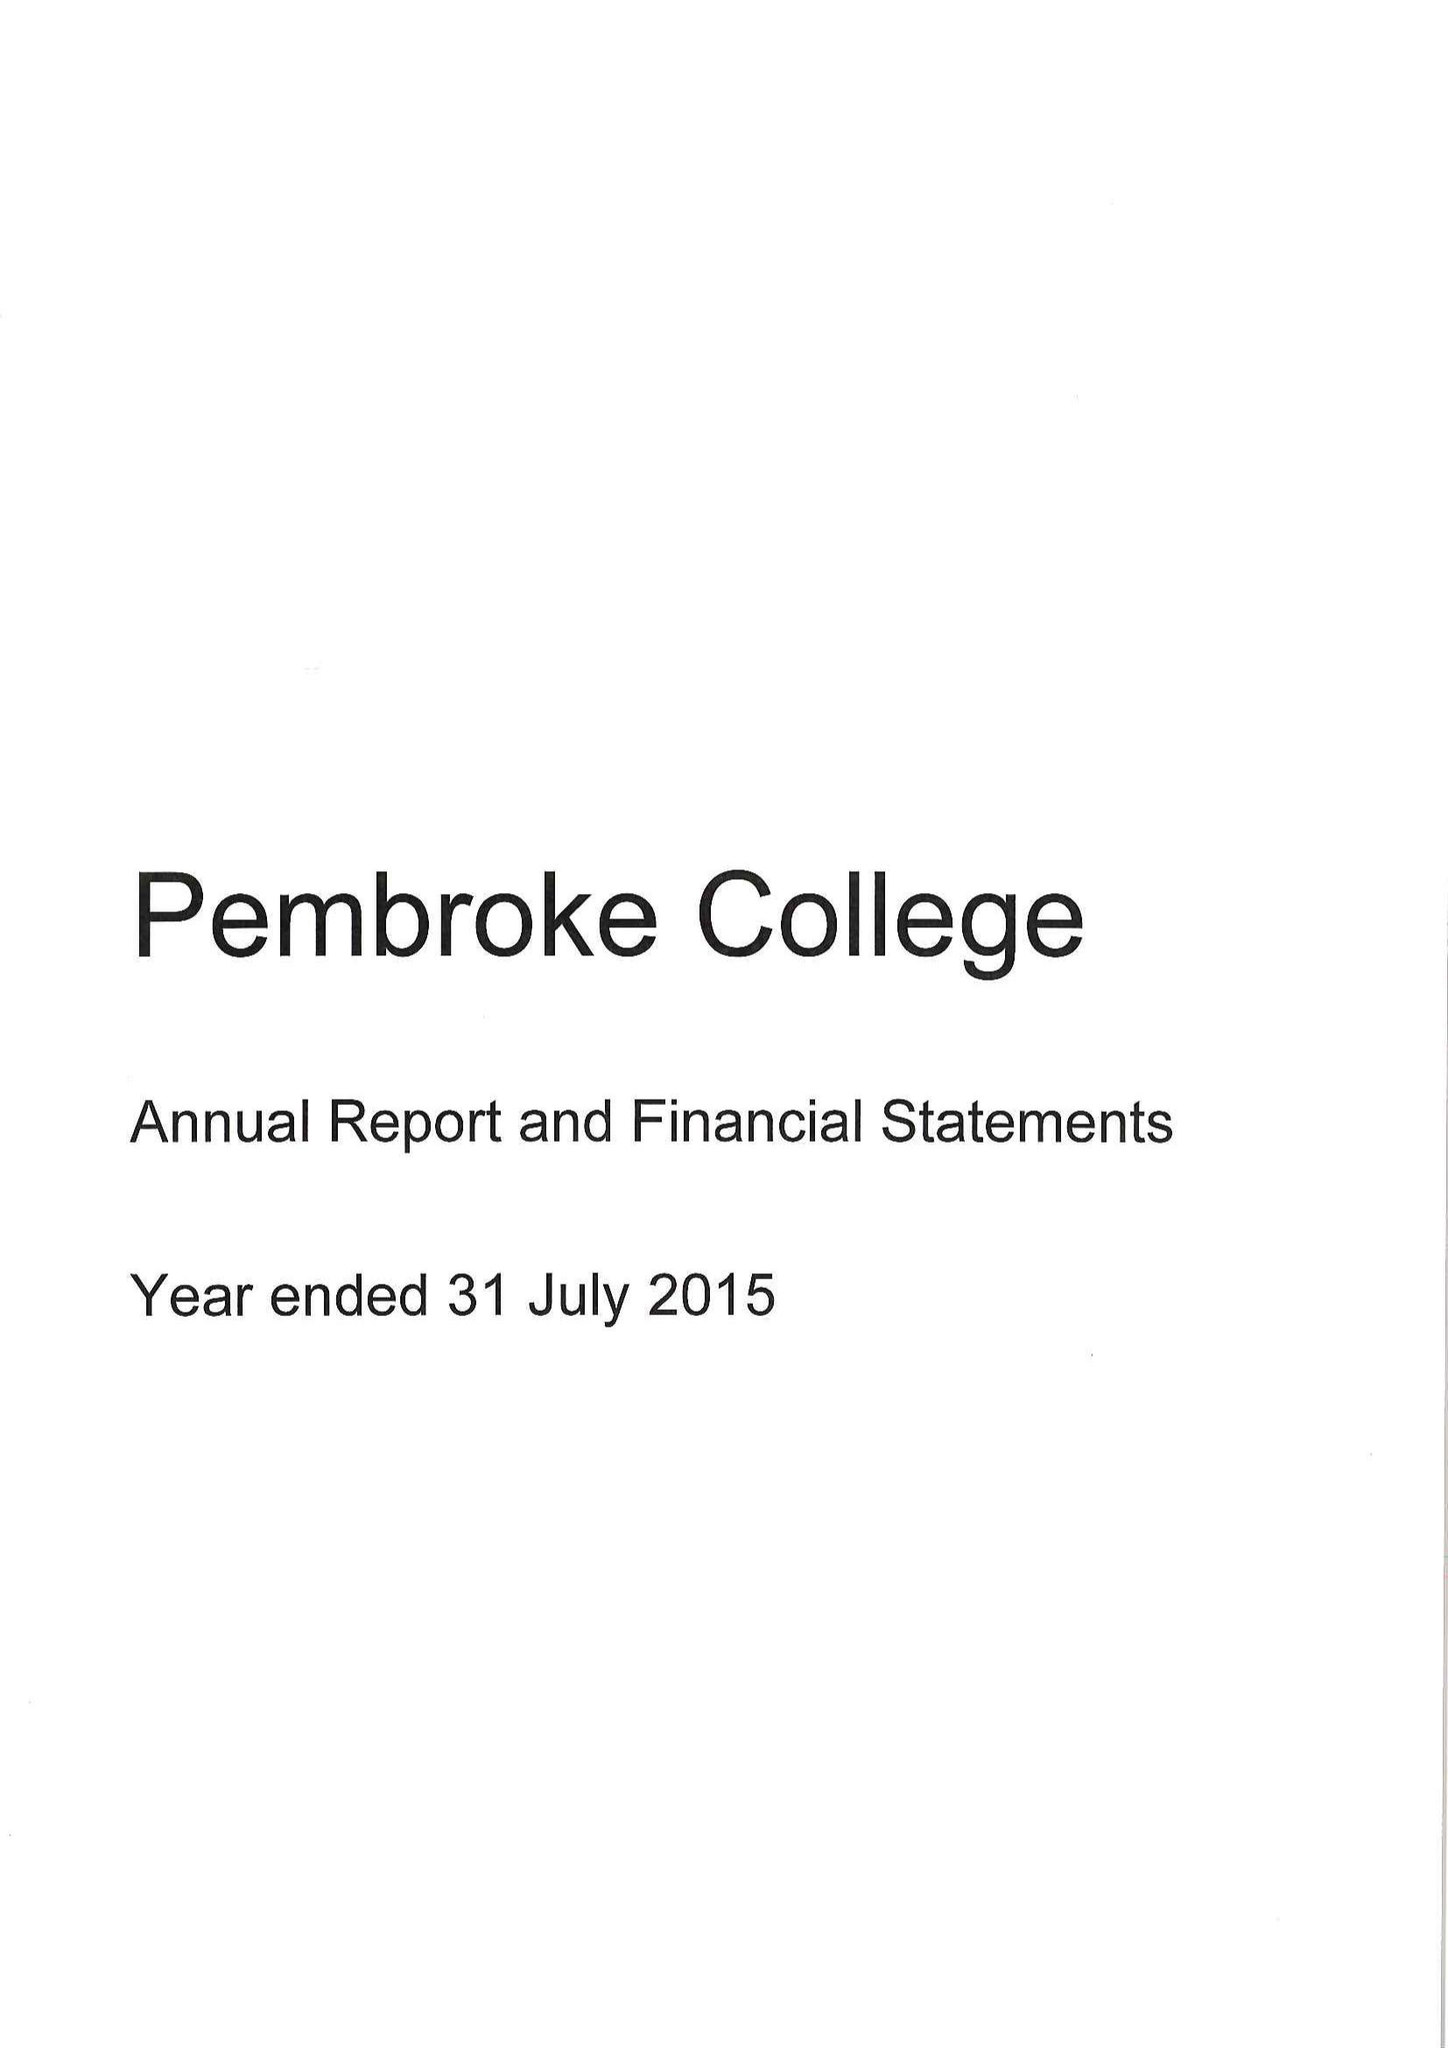What is the value for the address__post_town?
Answer the question using a single word or phrase. OXFORD 